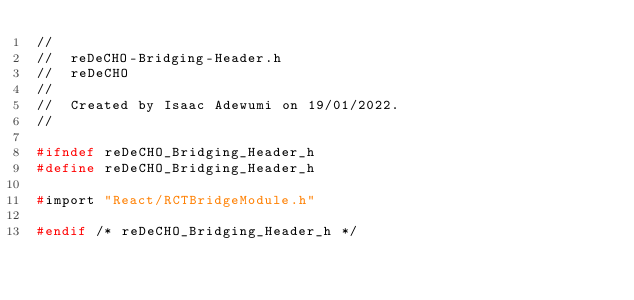<code> <loc_0><loc_0><loc_500><loc_500><_C_>//
//  reDeCHO-Bridging-Header.h
//  reDeCHO
//
//  Created by Isaac Adewumi on 19/01/2022.
//

#ifndef reDeCHO_Bridging_Header_h
#define reDeCHO_Bridging_Header_h

#import "React/RCTBridgeModule.h"

#endif /* reDeCHO_Bridging_Header_h */
</code> 